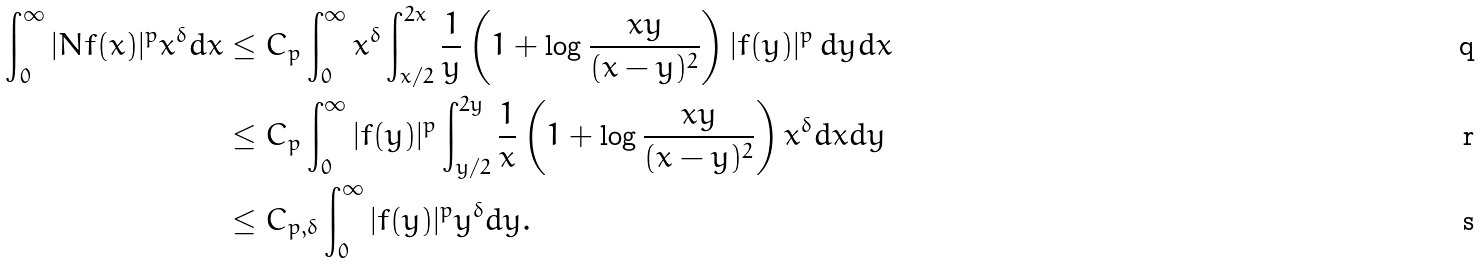Convert formula to latex. <formula><loc_0><loc_0><loc_500><loc_500>\int _ { 0 } ^ { \infty } | N f ( x ) | ^ { p } x ^ { \delta } d x & \leq C _ { p } \int _ { 0 } ^ { \infty } x ^ { \delta } \int _ { x / 2 } ^ { 2 x } \frac { 1 } { y } \left ( 1 + \log \frac { x y } { ( x - y ) ^ { 2 } } \right ) | f ( y ) | ^ { p } \, d y d x \\ & \leq C _ { p } \int _ { 0 } ^ { \infty } | f ( y ) | ^ { p } \int _ { y / 2 } ^ { 2 y } \frac { 1 } { x } \left ( 1 + \log \frac { x y } { ( x - y ) ^ { 2 } } \right ) x ^ { \delta } { d x } d y \\ & \leq C _ { p , \delta } \int _ { 0 } ^ { \infty } | f ( y ) | ^ { p } y ^ { \delta } d y .</formula> 